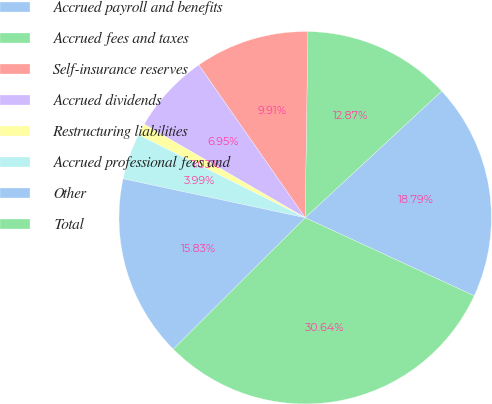Convert chart. <chart><loc_0><loc_0><loc_500><loc_500><pie_chart><fcel>Accrued payroll and benefits<fcel>Accrued fees and taxes<fcel>Self-insurance reserves<fcel>Accrued dividends<fcel>Restructuring liabilities<fcel>Accrued professional fees and<fcel>Other<fcel>Total<nl><fcel>18.79%<fcel>12.87%<fcel>9.91%<fcel>6.95%<fcel>1.03%<fcel>3.99%<fcel>15.83%<fcel>30.64%<nl></chart> 